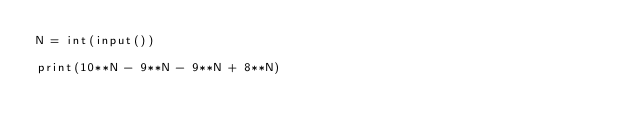<code> <loc_0><loc_0><loc_500><loc_500><_Python_>N = int(input())

print(10**N - 9**N - 9**N + 8**N)
</code> 